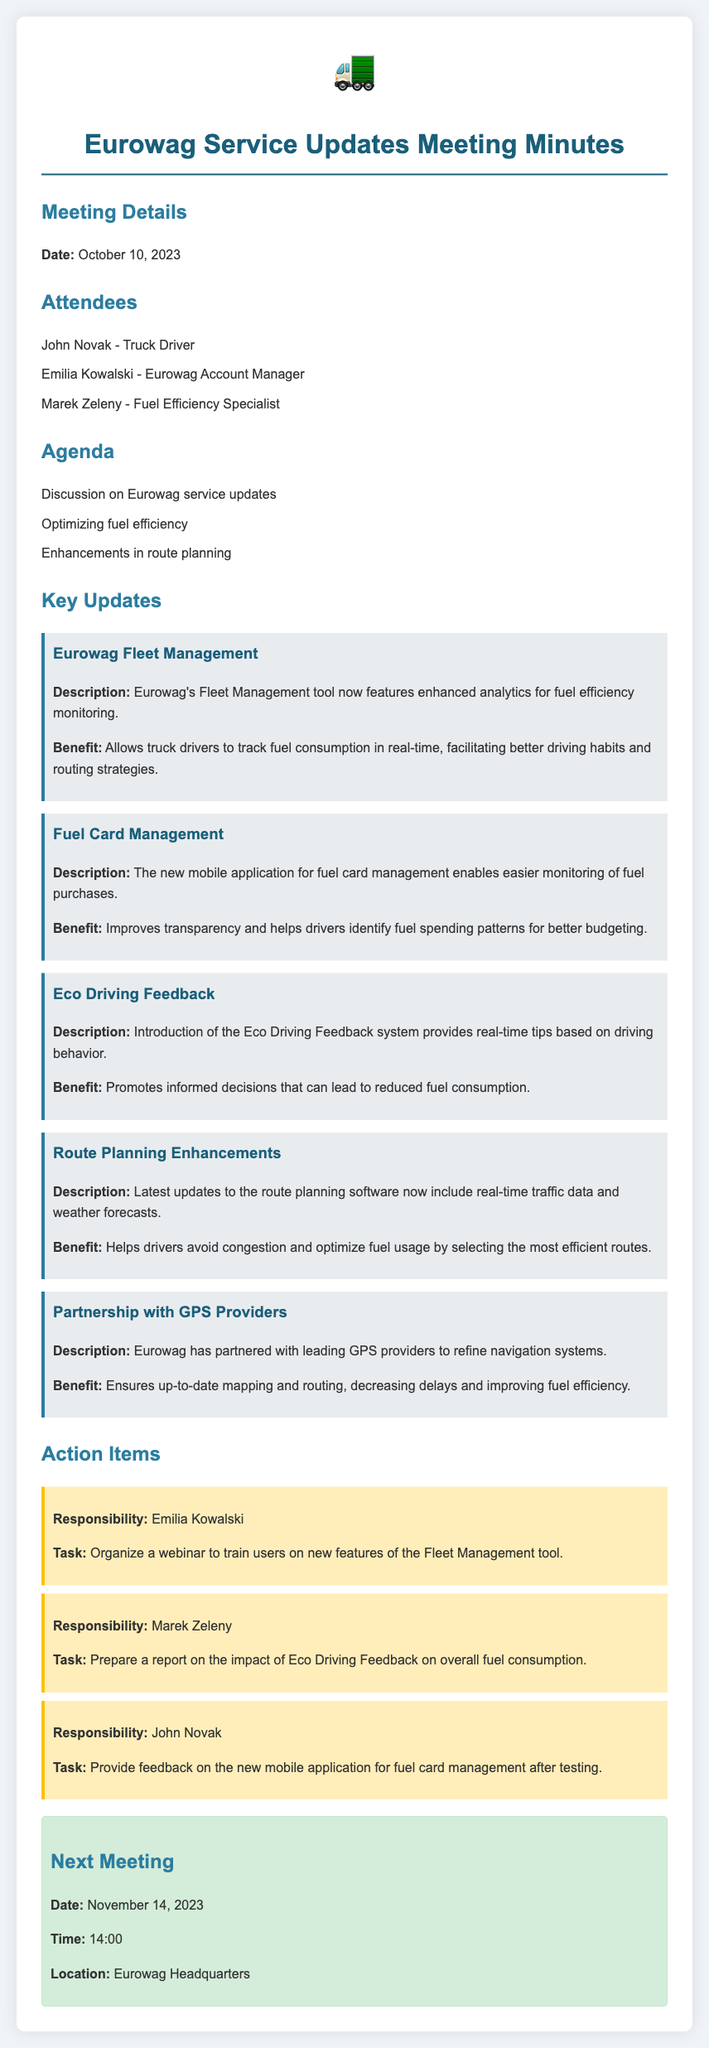What date was the meeting held? The meeting date is mentioned in the "Meeting Details" section of the document.
Answer: October 10, 2023 Who is the Fuel Efficiency Specialist? The document lists attendees, including their roles.
Answer: Marek Zeleny What new feature monitors fuel consumption in real-time? The updates mention specific tools and features that facilitate fuel tracking.
Answer: Fleet Management tool What task will Emilia Kowalski handle? Action items list the responsibilities assigned to attendees.
Answer: Organize a webinar What is one benefit of the Eco Driving Feedback system? The benefits of certain features are described.
Answer: Reduced fuel consumption What enhancements are included in the route planning software? The updates detail improvements made to existing services.
Answer: Real-time traffic data and weather forecasts Which date is the next scheduled meeting? This information is provided in the "Next Meeting" section.
Answer: November 14, 2023 What is the purpose of the partnership with GPS providers? The key updates describe the intent behind partnerships.
Answer: Improving fuel efficiency What will John Novak provide feedback on? The action items detail specific tasks assigned to attendees.
Answer: New mobile application for fuel card management 